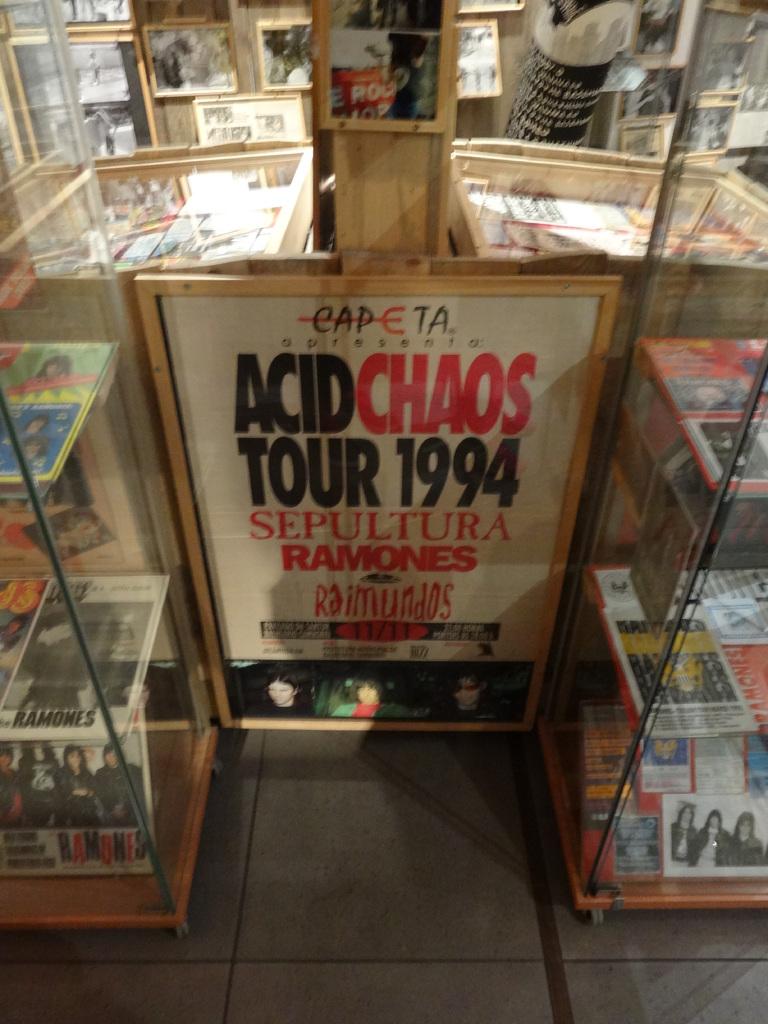What color is the word chaos?
Keep it short and to the point. Red. What year does the tour take place?
Your response must be concise. 1994. 